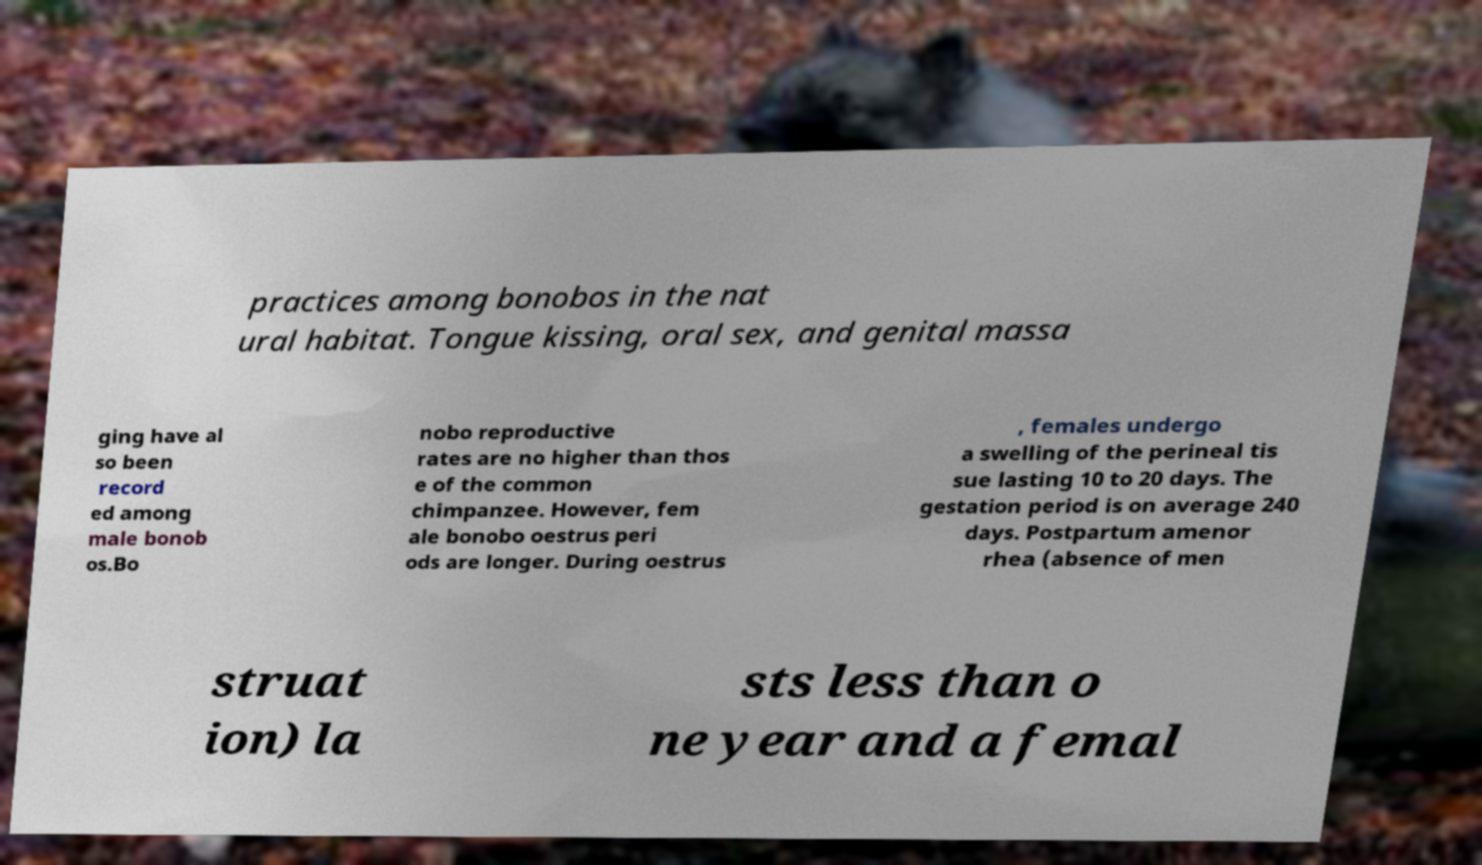Can you accurately transcribe the text from the provided image for me? practices among bonobos in the nat ural habitat. Tongue kissing, oral sex, and genital massa ging have al so been record ed among male bonob os.Bo nobo reproductive rates are no higher than thos e of the common chimpanzee. However, fem ale bonobo oestrus peri ods are longer. During oestrus , females undergo a swelling of the perineal tis sue lasting 10 to 20 days. The gestation period is on average 240 days. Postpartum amenor rhea (absence of men struat ion) la sts less than o ne year and a femal 